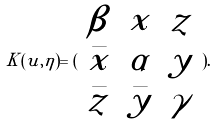<formula> <loc_0><loc_0><loc_500><loc_500>K ( u , \eta ) = ( \begin{array} { c c c } \beta & x & z \\ \bar { x } & \alpha & y \\ \bar { z } & \bar { y } & \gamma \end{array} ) .</formula> 